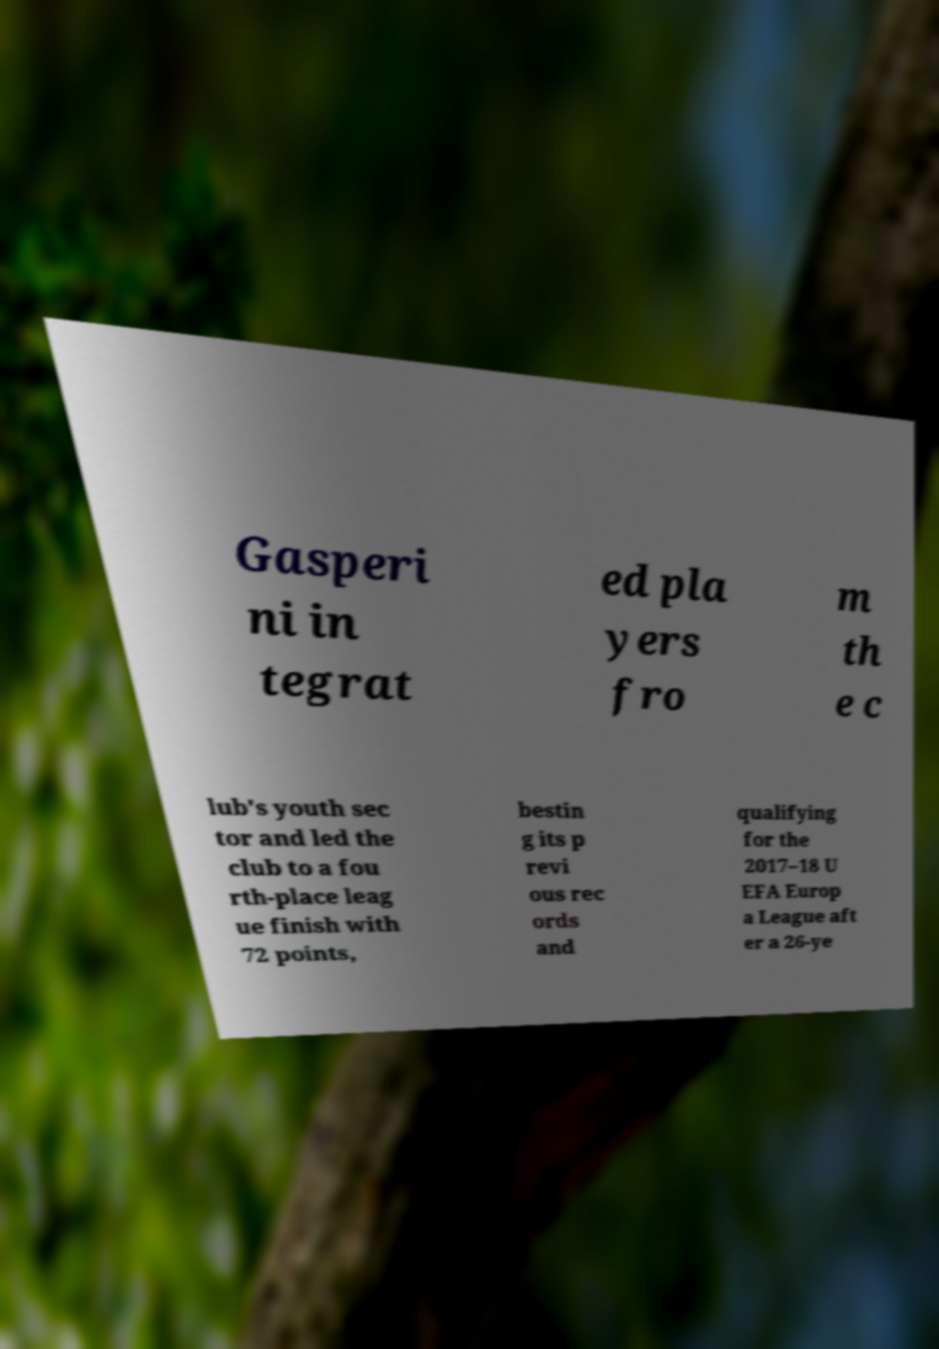Please read and relay the text visible in this image. What does it say? Gasperi ni in tegrat ed pla yers fro m th e c lub's youth sec tor and led the club to a fou rth-place leag ue finish with 72 points, bestin g its p revi ous rec ords and qualifying for the 2017–18 U EFA Europ a League aft er a 26-ye 